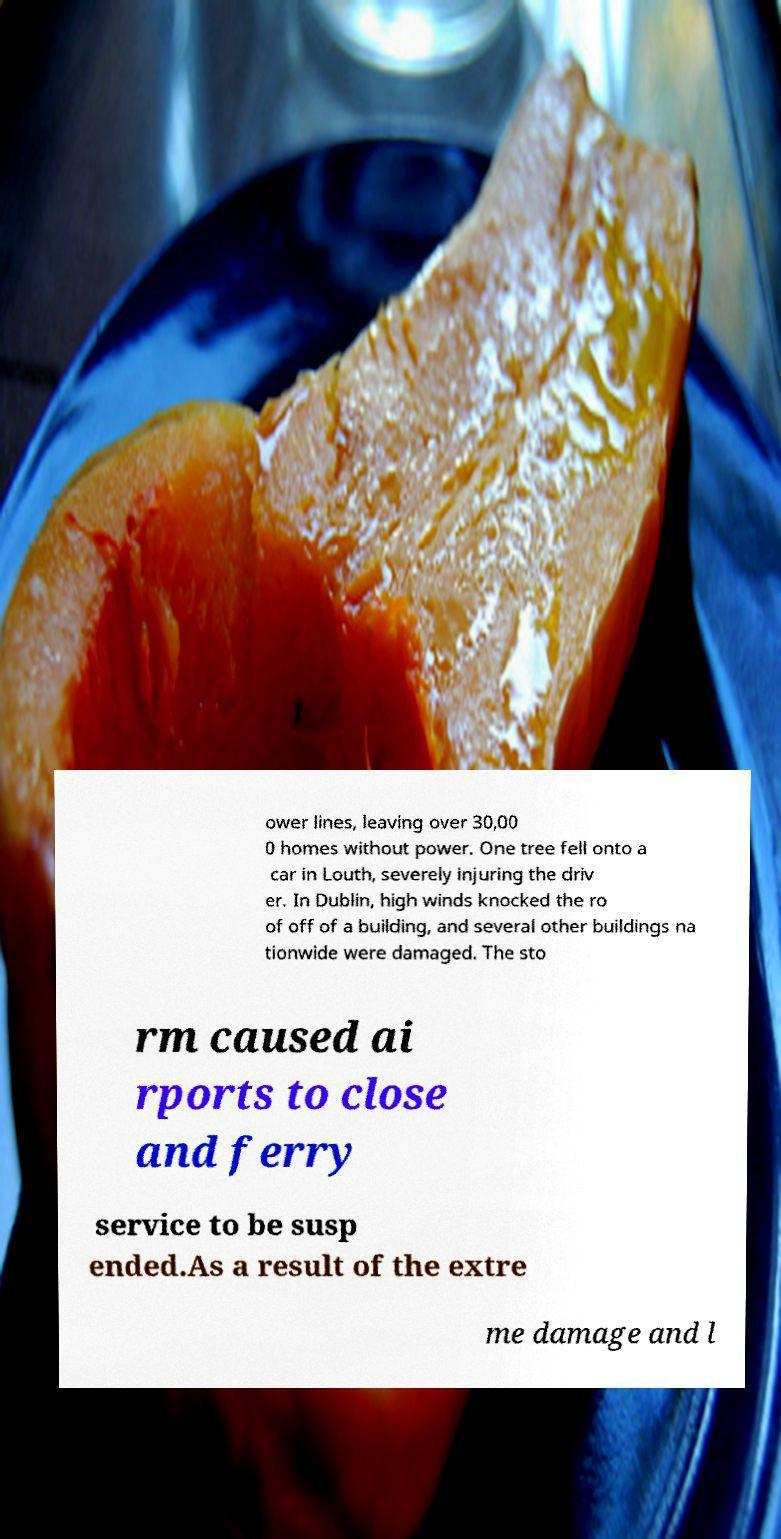Could you extract and type out the text from this image? ower lines, leaving over 30,00 0 homes without power. One tree fell onto a car in Louth, severely injuring the driv er. In Dublin, high winds knocked the ro of off of a building, and several other buildings na tionwide were damaged. The sto rm caused ai rports to close and ferry service to be susp ended.As a result of the extre me damage and l 